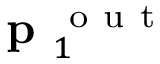Convert formula to latex. <formula><loc_0><loc_0><loc_500><loc_500>p _ { 1 } ^ { o u t }</formula> 